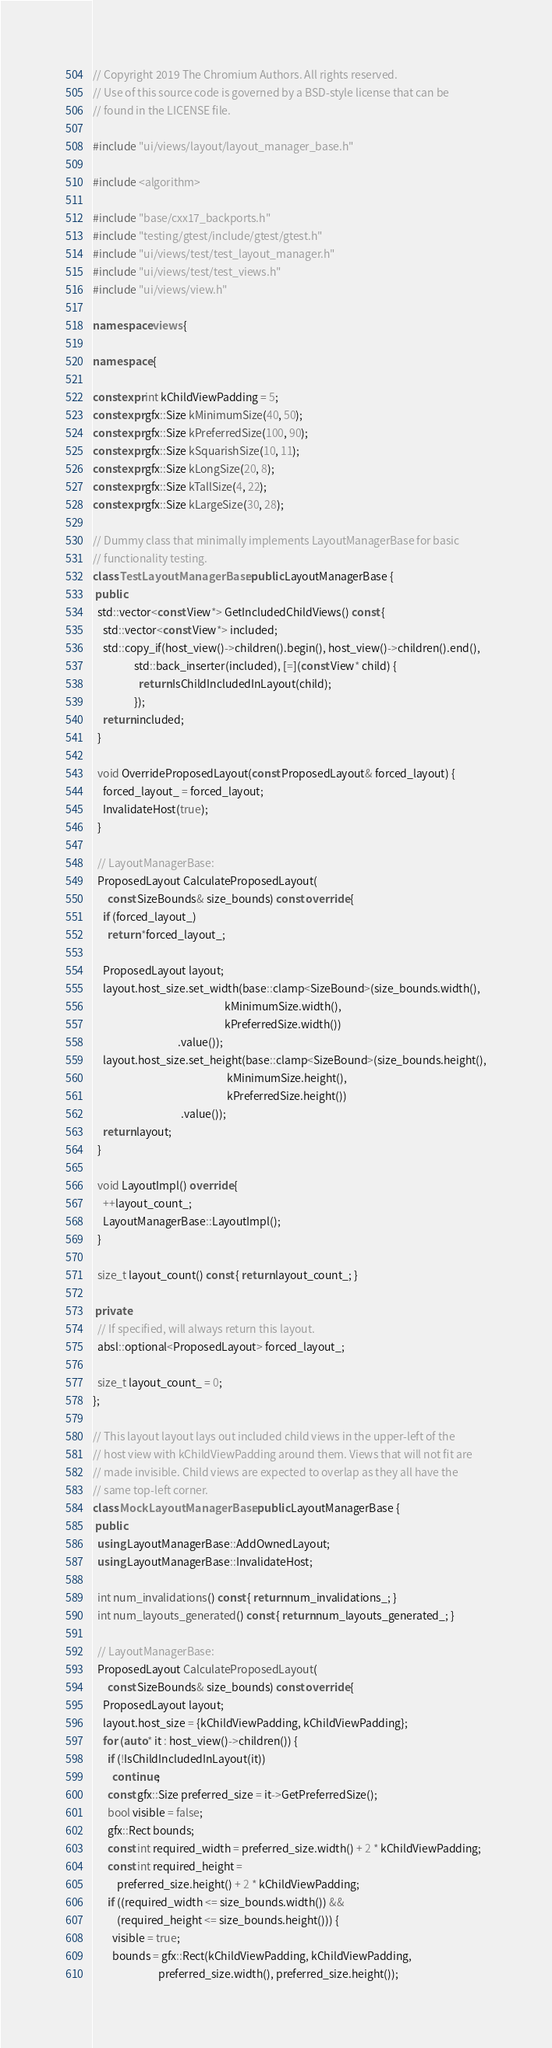Convert code to text. <code><loc_0><loc_0><loc_500><loc_500><_C++_>// Copyright 2019 The Chromium Authors. All rights reserved.
// Use of this source code is governed by a BSD-style license that can be
// found in the LICENSE file.

#include "ui/views/layout/layout_manager_base.h"

#include <algorithm>

#include "base/cxx17_backports.h"
#include "testing/gtest/include/gtest/gtest.h"
#include "ui/views/test/test_layout_manager.h"
#include "ui/views/test/test_views.h"
#include "ui/views/view.h"

namespace views {

namespace {

constexpr int kChildViewPadding = 5;
constexpr gfx::Size kMinimumSize(40, 50);
constexpr gfx::Size kPreferredSize(100, 90);
constexpr gfx::Size kSquarishSize(10, 11);
constexpr gfx::Size kLongSize(20, 8);
constexpr gfx::Size kTallSize(4, 22);
constexpr gfx::Size kLargeSize(30, 28);

// Dummy class that minimally implements LayoutManagerBase for basic
// functionality testing.
class TestLayoutManagerBase : public LayoutManagerBase {
 public:
  std::vector<const View*> GetIncludedChildViews() const {
    std::vector<const View*> included;
    std::copy_if(host_view()->children().begin(), host_view()->children().end(),
                 std::back_inserter(included), [=](const View* child) {
                   return IsChildIncludedInLayout(child);
                 });
    return included;
  }

  void OverrideProposedLayout(const ProposedLayout& forced_layout) {
    forced_layout_ = forced_layout;
    InvalidateHost(true);
  }

  // LayoutManagerBase:
  ProposedLayout CalculateProposedLayout(
      const SizeBounds& size_bounds) const override {
    if (forced_layout_)
      return *forced_layout_;

    ProposedLayout layout;
    layout.host_size.set_width(base::clamp<SizeBound>(size_bounds.width(),
                                                      kMinimumSize.width(),
                                                      kPreferredSize.width())
                                   .value());
    layout.host_size.set_height(base::clamp<SizeBound>(size_bounds.height(),
                                                       kMinimumSize.height(),
                                                       kPreferredSize.height())
                                    .value());
    return layout;
  }

  void LayoutImpl() override {
    ++layout_count_;
    LayoutManagerBase::LayoutImpl();
  }

  size_t layout_count() const { return layout_count_; }

 private:
  // If specified, will always return this layout.
  absl::optional<ProposedLayout> forced_layout_;

  size_t layout_count_ = 0;
};

// This layout layout lays out included child views in the upper-left of the
// host view with kChildViewPadding around them. Views that will not fit are
// made invisible. Child views are expected to overlap as they all have the
// same top-left corner.
class MockLayoutManagerBase : public LayoutManagerBase {
 public:
  using LayoutManagerBase::AddOwnedLayout;
  using LayoutManagerBase::InvalidateHost;

  int num_invalidations() const { return num_invalidations_; }
  int num_layouts_generated() const { return num_layouts_generated_; }

  // LayoutManagerBase:
  ProposedLayout CalculateProposedLayout(
      const SizeBounds& size_bounds) const override {
    ProposedLayout layout;
    layout.host_size = {kChildViewPadding, kChildViewPadding};
    for (auto* it : host_view()->children()) {
      if (!IsChildIncludedInLayout(it))
        continue;
      const gfx::Size preferred_size = it->GetPreferredSize();
      bool visible = false;
      gfx::Rect bounds;
      const int required_width = preferred_size.width() + 2 * kChildViewPadding;
      const int required_height =
          preferred_size.height() + 2 * kChildViewPadding;
      if ((required_width <= size_bounds.width()) &&
          (required_height <= size_bounds.height())) {
        visible = true;
        bounds = gfx::Rect(kChildViewPadding, kChildViewPadding,
                           preferred_size.width(), preferred_size.height());</code> 